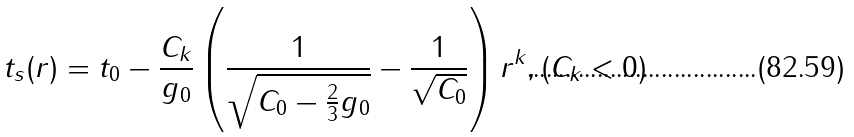<formula> <loc_0><loc_0><loc_500><loc_500>t _ { s } ( r ) = t _ { 0 } - \frac { C _ { k } } { g _ { 0 } } \left ( \frac { 1 } { \sqrt { C _ { 0 } - \frac { 2 } { 3 } g _ { 0 } } } - \frac { 1 } { \sqrt { C _ { 0 } } } \right ) r ^ { k } , ( C _ { k } < 0 )</formula> 